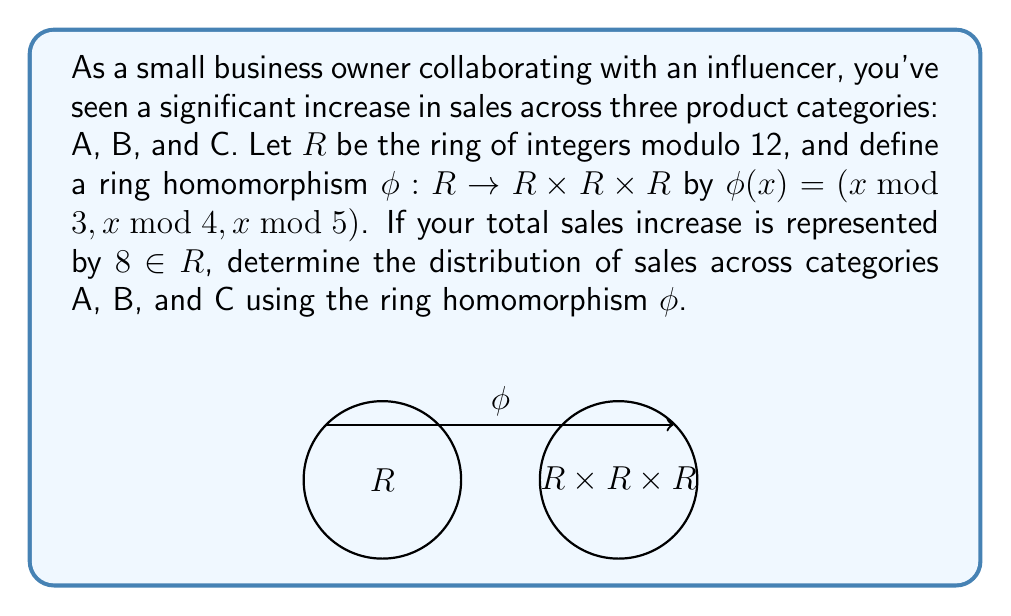Solve this math problem. Let's approach this step-by-step:

1) We need to compute $\phi(8)$, which will give us the distribution across the three categories.

2) Calculate $8 \bmod 3$:
   $8 \div 3 = 2$ remainder $2$
   So, $8 \bmod 3 = 2$

3) Calculate $8 \bmod 4$:
   $8 \div 4 = 2$ remainder $0$
   So, $8 \bmod 4 = 0$

4) Calculate $8 \bmod 5$:
   $8 \div 5 = 1$ remainder $3$
   So, $8 \bmod 5 = 3$

5) Therefore, $\phi(8) = (2, 0, 3)$

6) Interpreting the result:
   - Category A (represented by mod 3) received 2 units of increase
   - Category B (represented by mod 4) received 0 units of increase
   - Category C (represented by mod 5) received 3 units of increase

7) To verify that this is a valid distribution, we can check:
   $(2 \bmod 3) + (0 \bmod 4) + (3 \bmod 5) \equiv 2 + 0 + 3 \equiv 5 \equiv 8 \pmod{12}$

This confirms that the distribution is consistent with the total increase of 8 in $R$.
Answer: $(2, 0, 3)$ 